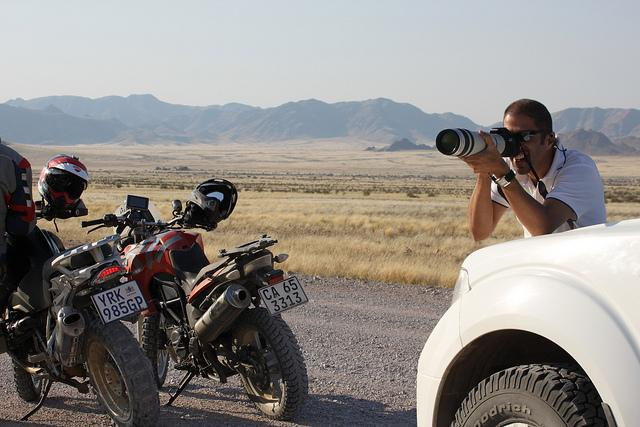How far away is the item being photographed?

Choices:
A) 2 feet
B) 10 feet
C) behind photographer
D) very far very far 